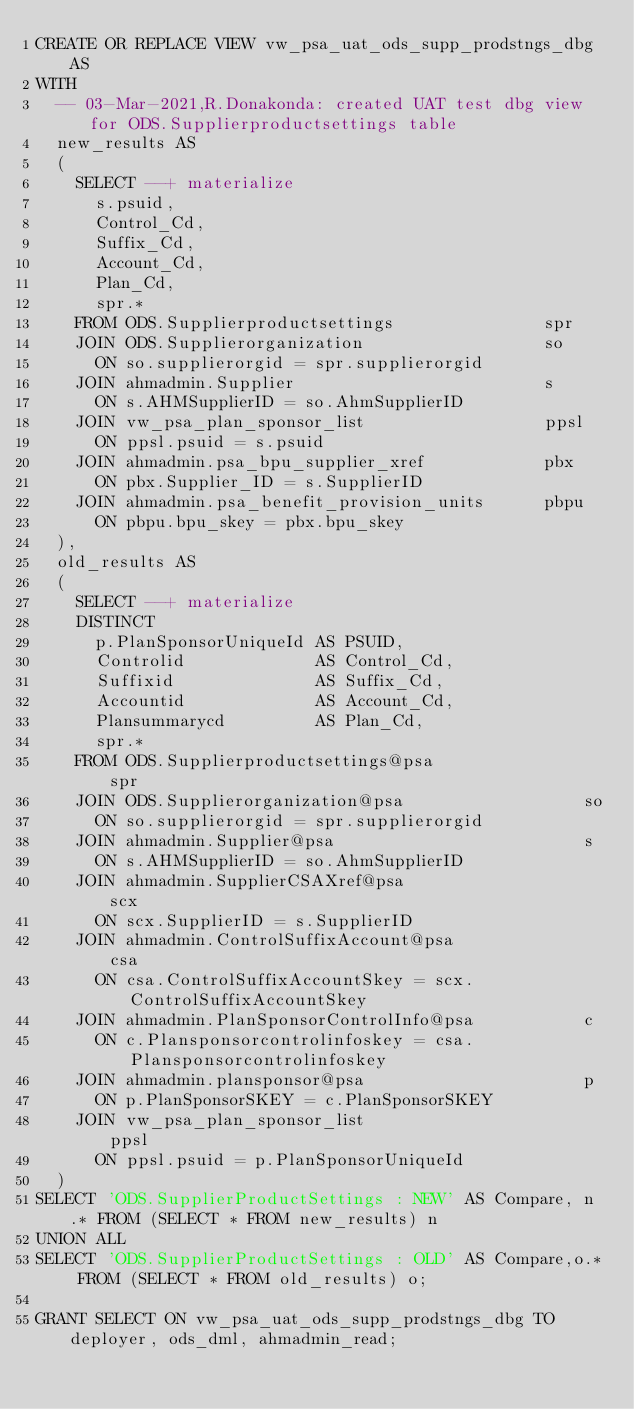Convert code to text. <code><loc_0><loc_0><loc_500><loc_500><_SQL_>CREATE OR REPLACE VIEW vw_psa_uat_ods_supp_prodstngs_dbg AS
WITH
  -- 03-Mar-2021,R.Donakonda: created UAT test dbg view for ODS.Supplierproductsettings table
  new_results AS
  (
    SELECT --+ materialize
      s.psuid,
      Control_Cd,
      Suffix_Cd,
      Account_Cd,
      Plan_Cd,
      spr.*
    FROM ODS.Supplierproductsettings               spr
    JOIN ODS.Supplierorganization                  so
      ON so.supplierorgid = spr.supplierorgid
    JOIN ahmadmin.Supplier                         s
      ON s.AHMSupplierID = so.AhmSupplierID
    JOIN vw_psa_plan_sponsor_list                  ppsl
      ON ppsl.psuid = s.psuid
    JOIN ahmadmin.psa_bpu_supplier_xref            pbx
      ON pbx.Supplier_ID = s.SupplierID
    JOIN ahmadmin.psa_benefit_provision_units      pbpu
      ON pbpu.bpu_skey = pbx.bpu_skey  
  ),      
  old_results AS
  (
    SELECT --+ materialize
    DISTINCT
      p.PlanSponsorUniqueId AS PSUID,
      Controlid             AS Control_Cd,
      Suffixid              AS Suffix_Cd,
      Accountid             AS Account_Cd,
      Plansummarycd         AS Plan_Cd,
      spr.*
    FROM ODS.Supplierproductsettings@psa               spr
    JOIN ODS.Supplierorganization@psa                  so
      ON so.supplierorgid = spr.supplierorgid
    JOIN ahmadmin.Supplier@psa                         s
      ON s.AHMSupplierID = so.AhmSupplierID
    JOIN ahmadmin.SupplierCSAXref@psa                  scx  
      ON scx.SupplierID = s.SupplierID
    JOIN ahmadmin.ControlSuffixAccount@psa             csa 
      ON csa.ControlSuffixAccountSkey = scx.ControlSuffixAccountSkey   
    JOIN ahmadmin.PlanSponsorControlInfo@psa           c 
      ON c.Plansponsorcontrolinfoskey = csa.Plansponsorcontrolinfoskey  
    JOIN ahmadmin.plansponsor@psa                      p 
      ON p.PlanSponsorSKEY = c.PlanSponsorSKEY 
    JOIN vw_psa_plan_sponsor_list                      ppsl
      ON ppsl.psuid = p.PlanSponsorUniqueId
  )
SELECT 'ODS.SupplierProductSettings : NEW' AS Compare, n.* FROM (SELECT * FROM new_results) n
UNION ALL
SELECT 'ODS.SupplierProductSettings : OLD' AS Compare,o.* FROM (SELECT * FROM old_results) o;

GRANT SELECT ON vw_psa_uat_ods_supp_prodstngs_dbg TO deployer, ods_dml, ahmadmin_read;
</code> 